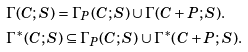<formula> <loc_0><loc_0><loc_500><loc_500>& \Gamma ( C ; S ) = \Gamma _ { P } ( C ; S ) \cup \Gamma ( C + P ; S ) . \\ & \Gamma ^ { \ast } ( C ; S ) \subseteq \Gamma _ { P } ( C ; S ) \cup \Gamma ^ { \ast } ( C + P ; S ) .</formula> 